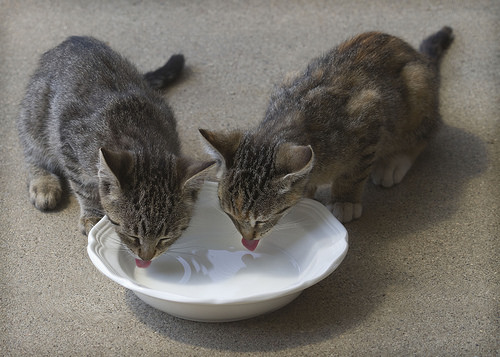<image>
Can you confirm if the cat is behind the bowl? Yes. From this viewpoint, the cat is positioned behind the bowl, with the bowl partially or fully occluding the cat. Where is the cat in relation to the cat? Is it behind the cat? No. The cat is not behind the cat. From this viewpoint, the cat appears to be positioned elsewhere in the scene. Where is the cat in relation to the cat? Is it to the left of the cat? Yes. From this viewpoint, the cat is positioned to the left side relative to the cat. 